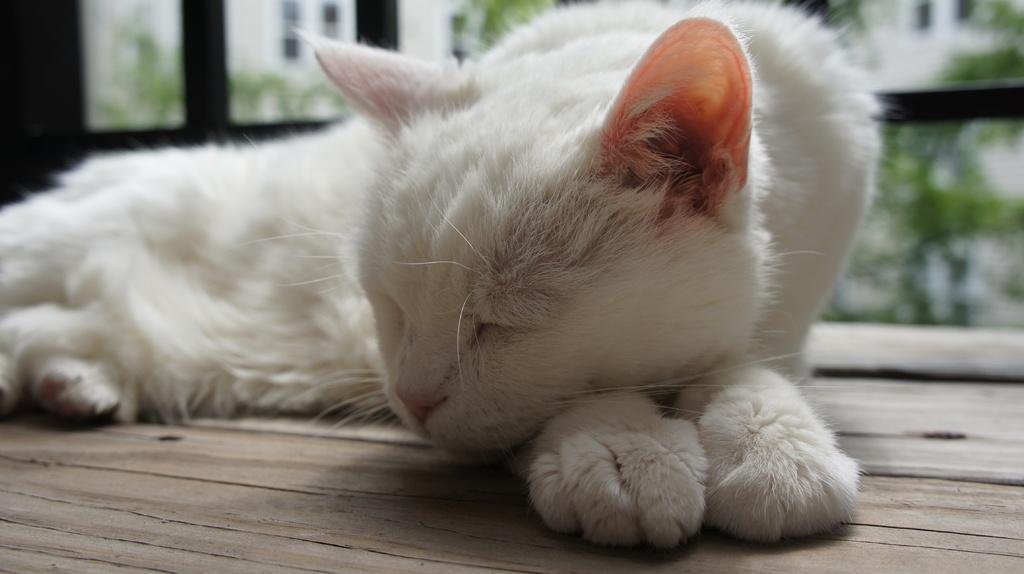Can you describe this image briefly? In this image we can see a cat. In the background of the image there are glass windows and an object. At the bottom of the image there is a wooden surface. 